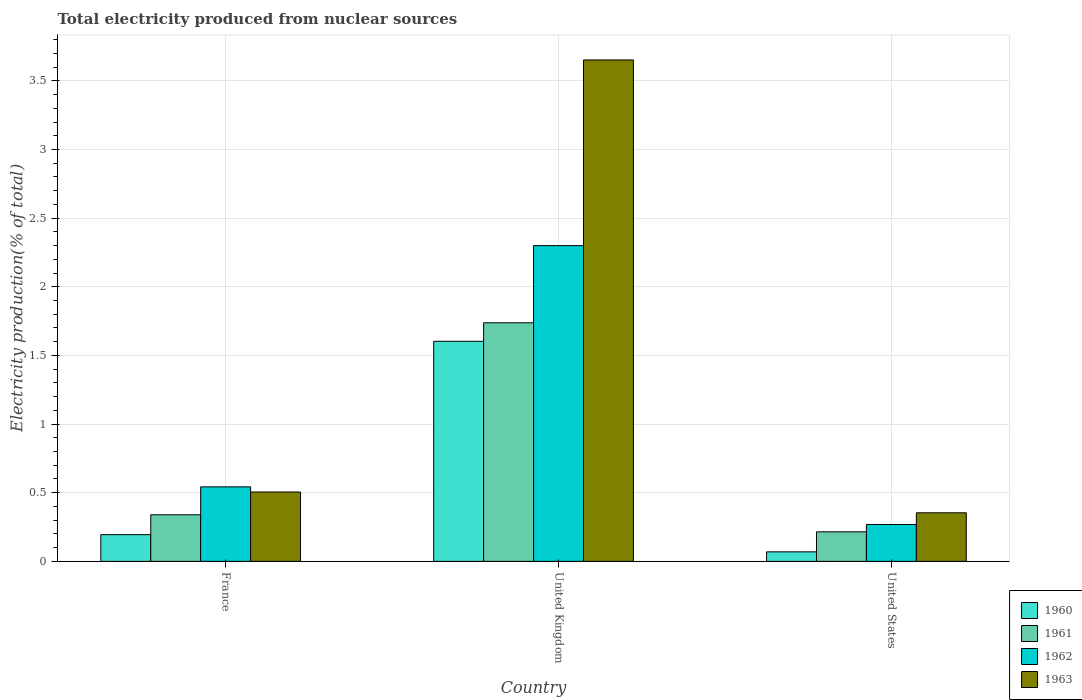How many different coloured bars are there?
Your response must be concise. 4. How many groups of bars are there?
Provide a succinct answer. 3. Are the number of bars on each tick of the X-axis equal?
Your answer should be very brief. Yes. How many bars are there on the 2nd tick from the left?
Keep it short and to the point. 4. How many bars are there on the 1st tick from the right?
Your answer should be very brief. 4. What is the total electricity produced in 1963 in France?
Give a very brief answer. 0.51. Across all countries, what is the maximum total electricity produced in 1962?
Your answer should be very brief. 2.3. Across all countries, what is the minimum total electricity produced in 1961?
Give a very brief answer. 0.22. In which country was the total electricity produced in 1963 maximum?
Make the answer very short. United Kingdom. In which country was the total electricity produced in 1961 minimum?
Offer a terse response. United States. What is the total total electricity produced in 1963 in the graph?
Provide a succinct answer. 4.51. What is the difference between the total electricity produced in 1962 in France and that in United Kingdom?
Your answer should be very brief. -1.76. What is the difference between the total electricity produced in 1963 in United States and the total electricity produced in 1962 in United Kingdom?
Your response must be concise. -1.95. What is the average total electricity produced in 1963 per country?
Keep it short and to the point. 1.5. What is the difference between the total electricity produced of/in 1960 and total electricity produced of/in 1962 in United Kingdom?
Make the answer very short. -0.7. What is the ratio of the total electricity produced in 1961 in France to that in United States?
Provide a succinct answer. 1.58. What is the difference between the highest and the second highest total electricity produced in 1962?
Keep it short and to the point. 0.27. What is the difference between the highest and the lowest total electricity produced in 1963?
Offer a terse response. 3.3. What does the 4th bar from the right in United States represents?
Your answer should be compact. 1960. Is it the case that in every country, the sum of the total electricity produced in 1961 and total electricity produced in 1960 is greater than the total electricity produced in 1962?
Make the answer very short. No. How many bars are there?
Keep it short and to the point. 12. Are all the bars in the graph horizontal?
Make the answer very short. No. Does the graph contain grids?
Keep it short and to the point. Yes. Where does the legend appear in the graph?
Make the answer very short. Bottom right. What is the title of the graph?
Keep it short and to the point. Total electricity produced from nuclear sources. What is the Electricity production(% of total) of 1960 in France?
Offer a very short reply. 0.19. What is the Electricity production(% of total) of 1961 in France?
Your response must be concise. 0.34. What is the Electricity production(% of total) in 1962 in France?
Your answer should be very brief. 0.54. What is the Electricity production(% of total) of 1963 in France?
Keep it short and to the point. 0.51. What is the Electricity production(% of total) in 1960 in United Kingdom?
Offer a terse response. 1.6. What is the Electricity production(% of total) in 1961 in United Kingdom?
Your response must be concise. 1.74. What is the Electricity production(% of total) in 1962 in United Kingdom?
Ensure brevity in your answer.  2.3. What is the Electricity production(% of total) of 1963 in United Kingdom?
Ensure brevity in your answer.  3.65. What is the Electricity production(% of total) of 1960 in United States?
Give a very brief answer. 0.07. What is the Electricity production(% of total) in 1961 in United States?
Provide a succinct answer. 0.22. What is the Electricity production(% of total) of 1962 in United States?
Offer a very short reply. 0.27. What is the Electricity production(% of total) in 1963 in United States?
Your answer should be very brief. 0.35. Across all countries, what is the maximum Electricity production(% of total) of 1960?
Provide a short and direct response. 1.6. Across all countries, what is the maximum Electricity production(% of total) in 1961?
Your answer should be very brief. 1.74. Across all countries, what is the maximum Electricity production(% of total) in 1962?
Your answer should be very brief. 2.3. Across all countries, what is the maximum Electricity production(% of total) in 1963?
Offer a terse response. 3.65. Across all countries, what is the minimum Electricity production(% of total) of 1960?
Give a very brief answer. 0.07. Across all countries, what is the minimum Electricity production(% of total) of 1961?
Ensure brevity in your answer.  0.22. Across all countries, what is the minimum Electricity production(% of total) in 1962?
Provide a succinct answer. 0.27. Across all countries, what is the minimum Electricity production(% of total) of 1963?
Provide a short and direct response. 0.35. What is the total Electricity production(% of total) in 1960 in the graph?
Ensure brevity in your answer.  1.87. What is the total Electricity production(% of total) in 1961 in the graph?
Provide a succinct answer. 2.29. What is the total Electricity production(% of total) in 1962 in the graph?
Offer a terse response. 3.11. What is the total Electricity production(% of total) of 1963 in the graph?
Keep it short and to the point. 4.51. What is the difference between the Electricity production(% of total) of 1960 in France and that in United Kingdom?
Provide a succinct answer. -1.41. What is the difference between the Electricity production(% of total) in 1961 in France and that in United Kingdom?
Keep it short and to the point. -1.4. What is the difference between the Electricity production(% of total) in 1962 in France and that in United Kingdom?
Keep it short and to the point. -1.76. What is the difference between the Electricity production(% of total) of 1963 in France and that in United Kingdom?
Keep it short and to the point. -3.15. What is the difference between the Electricity production(% of total) of 1960 in France and that in United States?
Your response must be concise. 0.13. What is the difference between the Electricity production(% of total) in 1961 in France and that in United States?
Your answer should be compact. 0.12. What is the difference between the Electricity production(% of total) of 1962 in France and that in United States?
Provide a short and direct response. 0.27. What is the difference between the Electricity production(% of total) of 1963 in France and that in United States?
Ensure brevity in your answer.  0.15. What is the difference between the Electricity production(% of total) in 1960 in United Kingdom and that in United States?
Your answer should be very brief. 1.53. What is the difference between the Electricity production(% of total) of 1961 in United Kingdom and that in United States?
Provide a short and direct response. 1.52. What is the difference between the Electricity production(% of total) of 1962 in United Kingdom and that in United States?
Give a very brief answer. 2.03. What is the difference between the Electricity production(% of total) of 1963 in United Kingdom and that in United States?
Keep it short and to the point. 3.3. What is the difference between the Electricity production(% of total) in 1960 in France and the Electricity production(% of total) in 1961 in United Kingdom?
Make the answer very short. -1.54. What is the difference between the Electricity production(% of total) in 1960 in France and the Electricity production(% of total) in 1962 in United Kingdom?
Provide a short and direct response. -2.11. What is the difference between the Electricity production(% of total) of 1960 in France and the Electricity production(% of total) of 1963 in United Kingdom?
Offer a very short reply. -3.46. What is the difference between the Electricity production(% of total) in 1961 in France and the Electricity production(% of total) in 1962 in United Kingdom?
Provide a short and direct response. -1.96. What is the difference between the Electricity production(% of total) in 1961 in France and the Electricity production(% of total) in 1963 in United Kingdom?
Provide a succinct answer. -3.31. What is the difference between the Electricity production(% of total) in 1962 in France and the Electricity production(% of total) in 1963 in United Kingdom?
Give a very brief answer. -3.11. What is the difference between the Electricity production(% of total) in 1960 in France and the Electricity production(% of total) in 1961 in United States?
Keep it short and to the point. -0.02. What is the difference between the Electricity production(% of total) in 1960 in France and the Electricity production(% of total) in 1962 in United States?
Offer a terse response. -0.07. What is the difference between the Electricity production(% of total) in 1960 in France and the Electricity production(% of total) in 1963 in United States?
Your answer should be compact. -0.16. What is the difference between the Electricity production(% of total) of 1961 in France and the Electricity production(% of total) of 1962 in United States?
Keep it short and to the point. 0.07. What is the difference between the Electricity production(% of total) of 1961 in France and the Electricity production(% of total) of 1963 in United States?
Your answer should be very brief. -0.01. What is the difference between the Electricity production(% of total) of 1962 in France and the Electricity production(% of total) of 1963 in United States?
Your response must be concise. 0.19. What is the difference between the Electricity production(% of total) in 1960 in United Kingdom and the Electricity production(% of total) in 1961 in United States?
Make the answer very short. 1.39. What is the difference between the Electricity production(% of total) in 1960 in United Kingdom and the Electricity production(% of total) in 1962 in United States?
Provide a short and direct response. 1.33. What is the difference between the Electricity production(% of total) in 1960 in United Kingdom and the Electricity production(% of total) in 1963 in United States?
Give a very brief answer. 1.25. What is the difference between the Electricity production(% of total) in 1961 in United Kingdom and the Electricity production(% of total) in 1962 in United States?
Make the answer very short. 1.47. What is the difference between the Electricity production(% of total) in 1961 in United Kingdom and the Electricity production(% of total) in 1963 in United States?
Keep it short and to the point. 1.38. What is the difference between the Electricity production(% of total) in 1962 in United Kingdom and the Electricity production(% of total) in 1963 in United States?
Provide a short and direct response. 1.95. What is the average Electricity production(% of total) in 1960 per country?
Your answer should be very brief. 0.62. What is the average Electricity production(% of total) of 1961 per country?
Provide a short and direct response. 0.76. What is the average Electricity production(% of total) in 1963 per country?
Your response must be concise. 1.5. What is the difference between the Electricity production(% of total) in 1960 and Electricity production(% of total) in 1961 in France?
Keep it short and to the point. -0.14. What is the difference between the Electricity production(% of total) of 1960 and Electricity production(% of total) of 1962 in France?
Your answer should be compact. -0.35. What is the difference between the Electricity production(% of total) of 1960 and Electricity production(% of total) of 1963 in France?
Provide a succinct answer. -0.31. What is the difference between the Electricity production(% of total) in 1961 and Electricity production(% of total) in 1962 in France?
Give a very brief answer. -0.2. What is the difference between the Electricity production(% of total) of 1961 and Electricity production(% of total) of 1963 in France?
Your response must be concise. -0.17. What is the difference between the Electricity production(% of total) in 1962 and Electricity production(% of total) in 1963 in France?
Provide a short and direct response. 0.04. What is the difference between the Electricity production(% of total) of 1960 and Electricity production(% of total) of 1961 in United Kingdom?
Give a very brief answer. -0.13. What is the difference between the Electricity production(% of total) in 1960 and Electricity production(% of total) in 1962 in United Kingdom?
Give a very brief answer. -0.7. What is the difference between the Electricity production(% of total) of 1960 and Electricity production(% of total) of 1963 in United Kingdom?
Keep it short and to the point. -2.05. What is the difference between the Electricity production(% of total) of 1961 and Electricity production(% of total) of 1962 in United Kingdom?
Your response must be concise. -0.56. What is the difference between the Electricity production(% of total) of 1961 and Electricity production(% of total) of 1963 in United Kingdom?
Make the answer very short. -1.91. What is the difference between the Electricity production(% of total) in 1962 and Electricity production(% of total) in 1963 in United Kingdom?
Provide a short and direct response. -1.35. What is the difference between the Electricity production(% of total) of 1960 and Electricity production(% of total) of 1961 in United States?
Make the answer very short. -0.15. What is the difference between the Electricity production(% of total) of 1960 and Electricity production(% of total) of 1962 in United States?
Your response must be concise. -0.2. What is the difference between the Electricity production(% of total) in 1960 and Electricity production(% of total) in 1963 in United States?
Offer a very short reply. -0.28. What is the difference between the Electricity production(% of total) of 1961 and Electricity production(% of total) of 1962 in United States?
Ensure brevity in your answer.  -0.05. What is the difference between the Electricity production(% of total) of 1961 and Electricity production(% of total) of 1963 in United States?
Your response must be concise. -0.14. What is the difference between the Electricity production(% of total) of 1962 and Electricity production(% of total) of 1963 in United States?
Provide a succinct answer. -0.09. What is the ratio of the Electricity production(% of total) of 1960 in France to that in United Kingdom?
Offer a very short reply. 0.12. What is the ratio of the Electricity production(% of total) in 1961 in France to that in United Kingdom?
Give a very brief answer. 0.2. What is the ratio of the Electricity production(% of total) of 1962 in France to that in United Kingdom?
Offer a very short reply. 0.24. What is the ratio of the Electricity production(% of total) in 1963 in France to that in United Kingdom?
Your answer should be compact. 0.14. What is the ratio of the Electricity production(% of total) in 1960 in France to that in United States?
Keep it short and to the point. 2.81. What is the ratio of the Electricity production(% of total) in 1961 in France to that in United States?
Provide a short and direct response. 1.58. What is the ratio of the Electricity production(% of total) in 1962 in France to that in United States?
Keep it short and to the point. 2.02. What is the ratio of the Electricity production(% of total) in 1963 in France to that in United States?
Your response must be concise. 1.43. What is the ratio of the Electricity production(% of total) in 1960 in United Kingdom to that in United States?
Make the answer very short. 23.14. What is the ratio of the Electricity production(% of total) in 1961 in United Kingdom to that in United States?
Ensure brevity in your answer.  8.08. What is the ratio of the Electricity production(% of total) of 1962 in United Kingdom to that in United States?
Your response must be concise. 8.56. What is the ratio of the Electricity production(% of total) in 1963 in United Kingdom to that in United States?
Provide a succinct answer. 10.32. What is the difference between the highest and the second highest Electricity production(% of total) of 1960?
Provide a succinct answer. 1.41. What is the difference between the highest and the second highest Electricity production(% of total) of 1961?
Your answer should be compact. 1.4. What is the difference between the highest and the second highest Electricity production(% of total) of 1962?
Offer a terse response. 1.76. What is the difference between the highest and the second highest Electricity production(% of total) of 1963?
Your response must be concise. 3.15. What is the difference between the highest and the lowest Electricity production(% of total) in 1960?
Your answer should be very brief. 1.53. What is the difference between the highest and the lowest Electricity production(% of total) in 1961?
Keep it short and to the point. 1.52. What is the difference between the highest and the lowest Electricity production(% of total) in 1962?
Keep it short and to the point. 2.03. What is the difference between the highest and the lowest Electricity production(% of total) of 1963?
Make the answer very short. 3.3. 